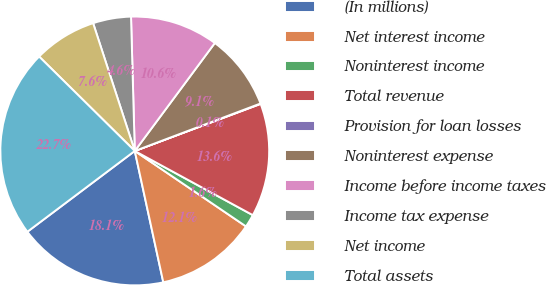Convert chart. <chart><loc_0><loc_0><loc_500><loc_500><pie_chart><fcel>(In millions)<fcel>Net interest income<fcel>Noninterest income<fcel>Total revenue<fcel>Provision for loan losses<fcel>Noninterest expense<fcel>Income before income taxes<fcel>Income tax expense<fcel>Net income<fcel>Total assets<nl><fcel>18.14%<fcel>12.11%<fcel>1.56%<fcel>13.62%<fcel>0.05%<fcel>9.1%<fcel>10.6%<fcel>4.57%<fcel>7.59%<fcel>22.66%<nl></chart> 